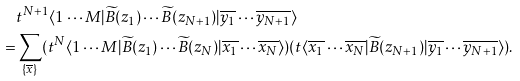<formula> <loc_0><loc_0><loc_500><loc_500>& t ^ { N + 1 } \langle 1 \cdots M | \widetilde { B } ( z _ { 1 } ) \cdots \widetilde { B } ( z _ { N + 1 } ) | \overline { y _ { 1 } } \cdots \overline { y _ { N + 1 } } \rangle \\ = & \sum _ { \{ \overline { x } \} } ( t ^ { N } \langle 1 \cdots M | \widetilde { B } ( z _ { 1 } ) \cdots \widetilde { B } ( z _ { N } ) | \overline { x _ { 1 } } \cdots \overline { x _ { N } } \rangle ) ( t \langle \overline { x _ { 1 } } \cdots \overline { x _ { N } } | \widetilde { B } ( z _ { N + 1 } ) | \overline { y _ { 1 } } \cdots \overline { y _ { N + 1 } } \rangle ) .</formula> 